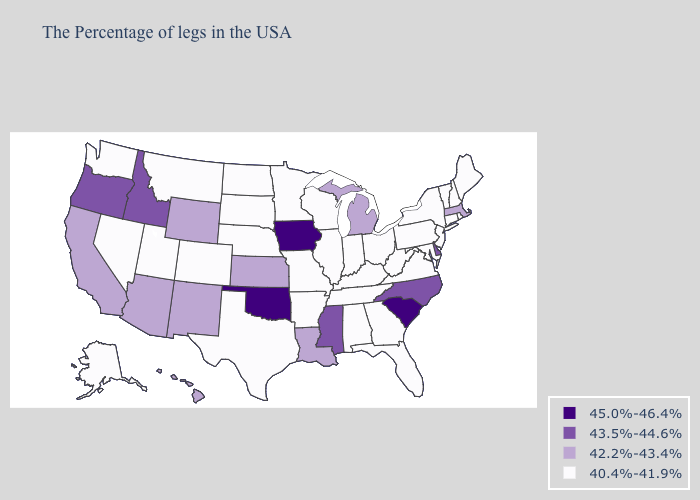Name the states that have a value in the range 43.5%-44.6%?
Short answer required. Delaware, North Carolina, Mississippi, Idaho, Oregon. What is the value of Ohio?
Quick response, please. 40.4%-41.9%. Does Montana have the same value as Oregon?
Write a very short answer. No. Among the states that border Utah , which have the lowest value?
Keep it brief. Colorado, Nevada. What is the highest value in the USA?
Be succinct. 45.0%-46.4%. Is the legend a continuous bar?
Give a very brief answer. No. Does Hawaii have the highest value in the West?
Concise answer only. No. Does Idaho have the highest value in the West?
Answer briefly. Yes. Does the first symbol in the legend represent the smallest category?
Answer briefly. No. Does Wisconsin have the lowest value in the MidWest?
Concise answer only. Yes. What is the lowest value in the MidWest?
Short answer required. 40.4%-41.9%. Among the states that border Indiana , does Illinois have the lowest value?
Quick response, please. Yes. Does Kentucky have the lowest value in the USA?
Answer briefly. Yes. Does Illinois have the lowest value in the MidWest?
Give a very brief answer. Yes. Among the states that border Kentucky , which have the highest value?
Answer briefly. Virginia, West Virginia, Ohio, Indiana, Tennessee, Illinois, Missouri. 